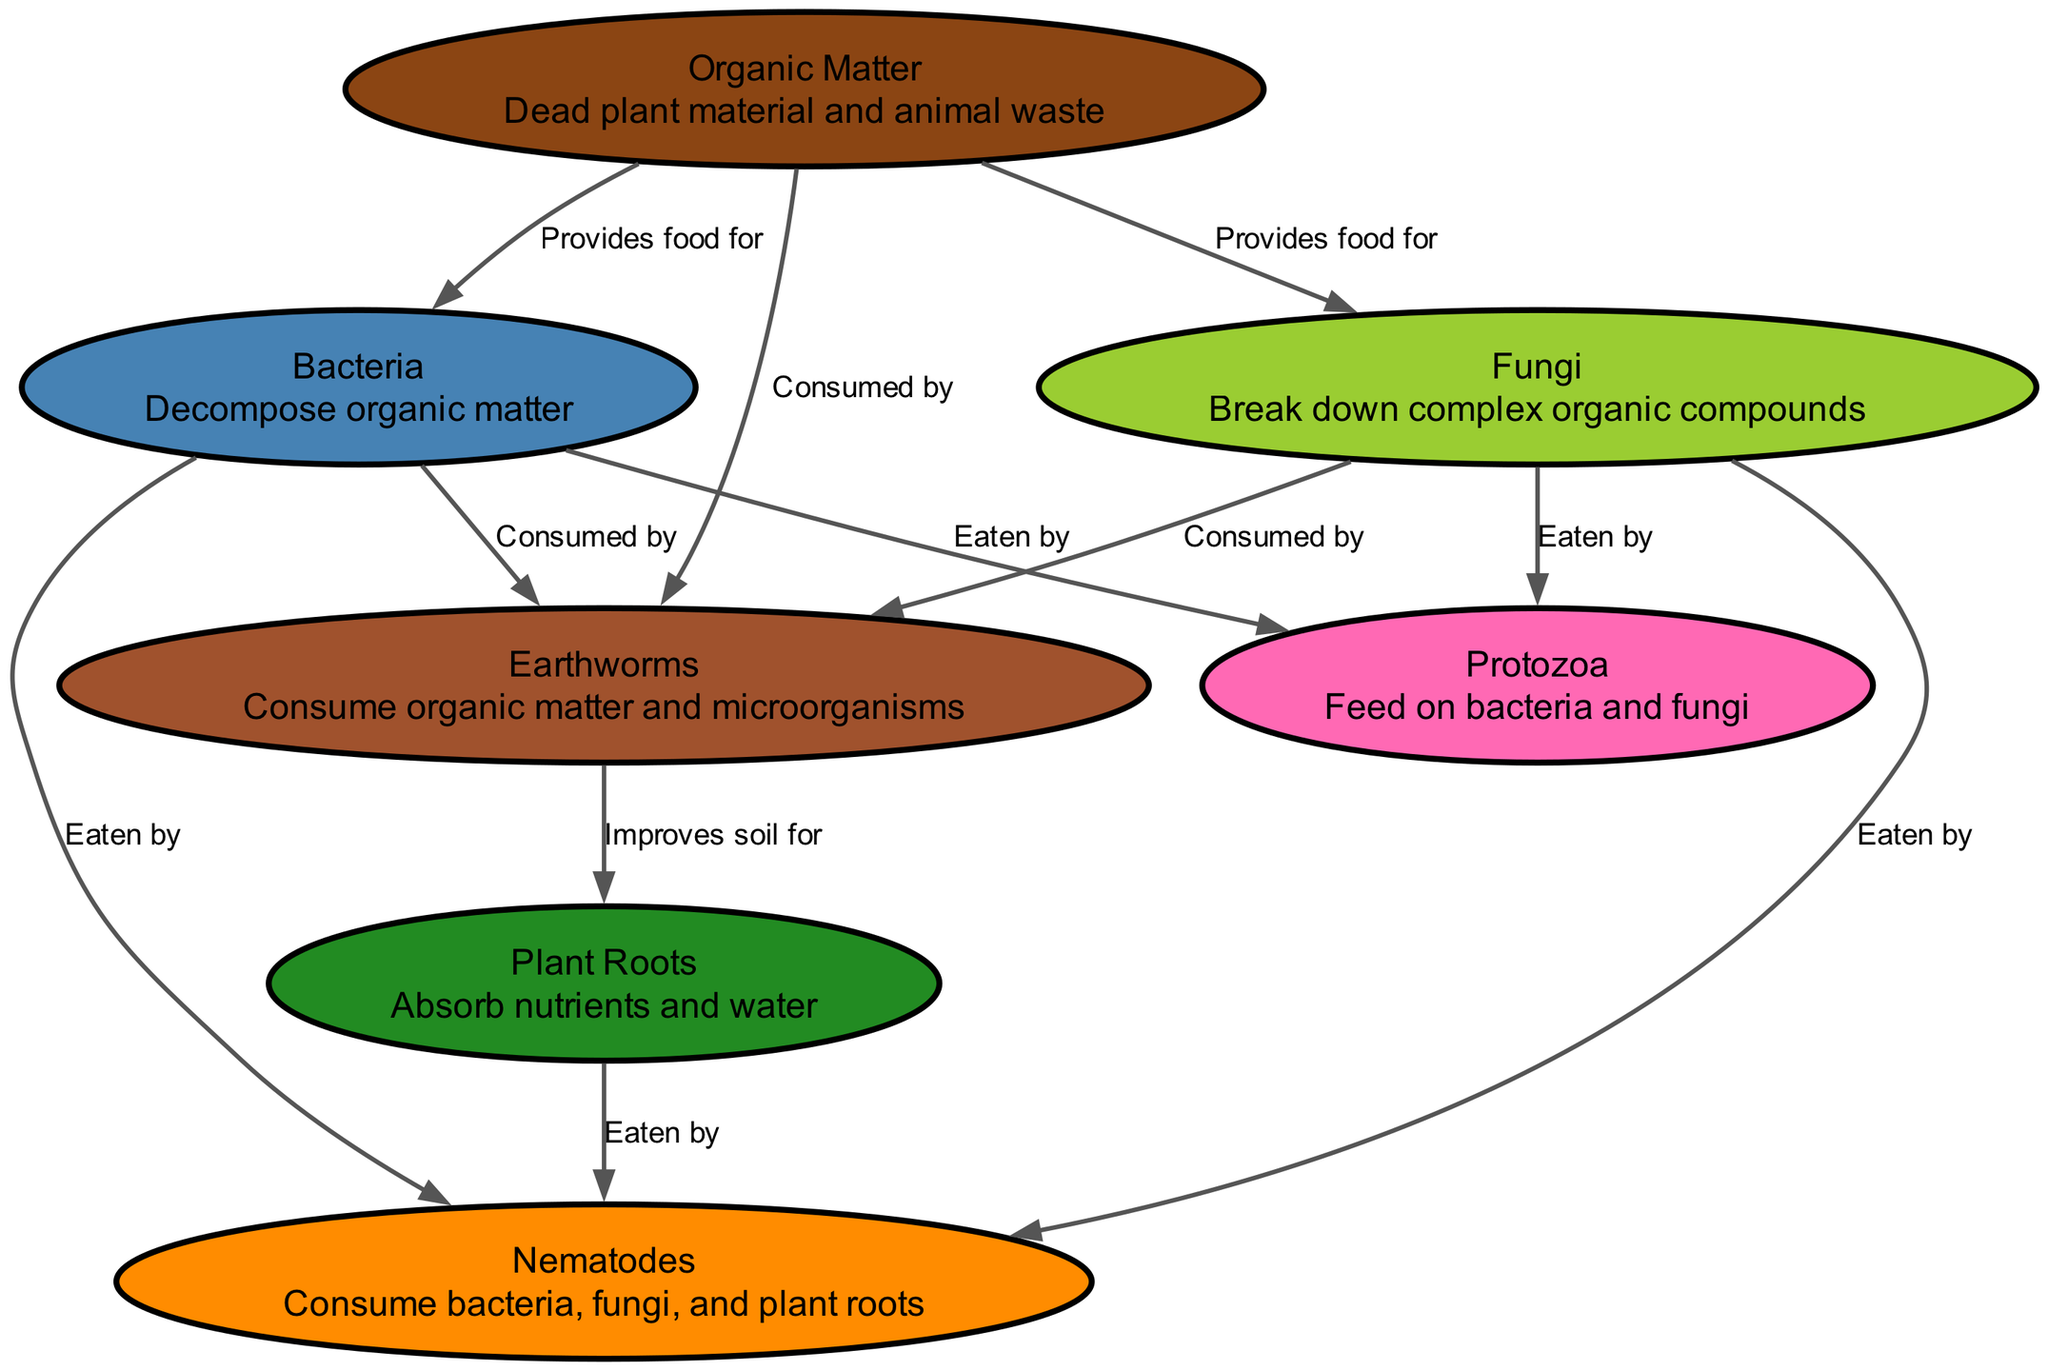What is the total number of nodes in the diagram? The diagram includes seven distinct entities, each representing a component of the soil food web. Counting all the unique nodes listed yields a total of seven nodes.
Answer: 7 Which organism is classified as decomposers in the soil food web? The diagram categorizes both bacteria and fungi as decomposers, as they both break down organic matter into simpler substances for consumption by other soil organisms.
Answer: Bacteria, Fungi Which organisms are known to feed on bacteria according to the diagram? The diagram indicates that both protozoa and nematodes consume bacteria, showing a direct feeding relationship where these organisms utilize bacteria as a food source.
Answer: Protozoa, Nematodes How many edges are present in the diagram? To determine the total edges, we count the links showing relationships between nodes. The diagram consists of eleven edges illustrating the interactions and flows between various components of the soil food web.
Answer: 11 What role do earthworms play in the soil food web? According to the diagram, earthworms consume organic matter and microorganisms, indicating their role as consumers within the soil food web that helps recycle nutrients in the soil.
Answer: Consume organic matter and microorganisms Which organism improves soil for plant roots? The diagram indicates that earthworms improve soil conditions for plant roots, highlighting their beneficial role in enhancing soil structure and aeration, which is vital for root health.
Answer: Earthworms What do plant roots absorb from the soil? The diagram specifies that plant roots absorb nutrients and water, showcasing their critical function in obtaining essential resources needed for plant growth.
Answer: Nutrients and water Which organisms are eaten by nematodes? The diagram shows that nematodes feed on bacteria, fungi, and plant roots. This indicates that nematodes are omnivorous and have a varied diet consisting of different soil organisms.
Answer: Bacteria, Fungi, Plant Roots How do fungi contribute to the soil food web? The diagram illustrates that fungi break down complex organic compounds and are also food for both protozoa and nematodes, indicating their dual role as decomposers and a food source in the web.
Answer: Decompose organic compounds, food for protozoa and nematodes 